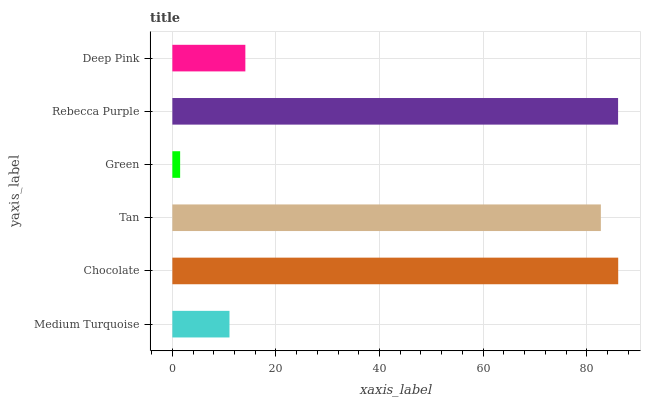Is Green the minimum?
Answer yes or no. Yes. Is Chocolate the maximum?
Answer yes or no. Yes. Is Tan the minimum?
Answer yes or no. No. Is Tan the maximum?
Answer yes or no. No. Is Chocolate greater than Tan?
Answer yes or no. Yes. Is Tan less than Chocolate?
Answer yes or no. Yes. Is Tan greater than Chocolate?
Answer yes or no. No. Is Chocolate less than Tan?
Answer yes or no. No. Is Tan the high median?
Answer yes or no. Yes. Is Deep Pink the low median?
Answer yes or no. Yes. Is Medium Turquoise the high median?
Answer yes or no. No. Is Rebecca Purple the low median?
Answer yes or no. No. 